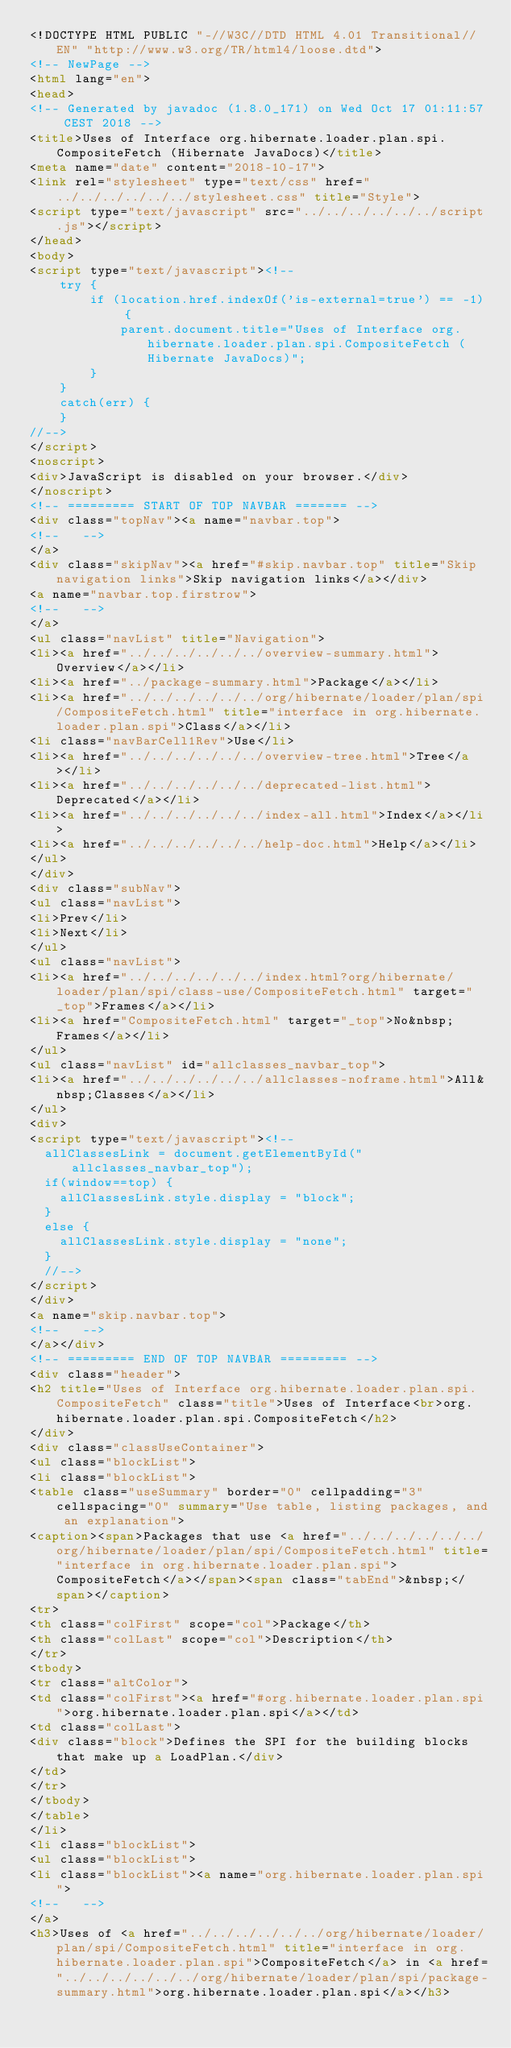Convert code to text. <code><loc_0><loc_0><loc_500><loc_500><_HTML_><!DOCTYPE HTML PUBLIC "-//W3C//DTD HTML 4.01 Transitional//EN" "http://www.w3.org/TR/html4/loose.dtd">
<!-- NewPage -->
<html lang="en">
<head>
<!-- Generated by javadoc (1.8.0_171) on Wed Oct 17 01:11:57 CEST 2018 -->
<title>Uses of Interface org.hibernate.loader.plan.spi.CompositeFetch (Hibernate JavaDocs)</title>
<meta name="date" content="2018-10-17">
<link rel="stylesheet" type="text/css" href="../../../../../../stylesheet.css" title="Style">
<script type="text/javascript" src="../../../../../../script.js"></script>
</head>
<body>
<script type="text/javascript"><!--
    try {
        if (location.href.indexOf('is-external=true') == -1) {
            parent.document.title="Uses of Interface org.hibernate.loader.plan.spi.CompositeFetch (Hibernate JavaDocs)";
        }
    }
    catch(err) {
    }
//-->
</script>
<noscript>
<div>JavaScript is disabled on your browser.</div>
</noscript>
<!-- ========= START OF TOP NAVBAR ======= -->
<div class="topNav"><a name="navbar.top">
<!--   -->
</a>
<div class="skipNav"><a href="#skip.navbar.top" title="Skip navigation links">Skip navigation links</a></div>
<a name="navbar.top.firstrow">
<!--   -->
</a>
<ul class="navList" title="Navigation">
<li><a href="../../../../../../overview-summary.html">Overview</a></li>
<li><a href="../package-summary.html">Package</a></li>
<li><a href="../../../../../../org/hibernate/loader/plan/spi/CompositeFetch.html" title="interface in org.hibernate.loader.plan.spi">Class</a></li>
<li class="navBarCell1Rev">Use</li>
<li><a href="../../../../../../overview-tree.html">Tree</a></li>
<li><a href="../../../../../../deprecated-list.html">Deprecated</a></li>
<li><a href="../../../../../../index-all.html">Index</a></li>
<li><a href="../../../../../../help-doc.html">Help</a></li>
</ul>
</div>
<div class="subNav">
<ul class="navList">
<li>Prev</li>
<li>Next</li>
</ul>
<ul class="navList">
<li><a href="../../../../../../index.html?org/hibernate/loader/plan/spi/class-use/CompositeFetch.html" target="_top">Frames</a></li>
<li><a href="CompositeFetch.html" target="_top">No&nbsp;Frames</a></li>
</ul>
<ul class="navList" id="allclasses_navbar_top">
<li><a href="../../../../../../allclasses-noframe.html">All&nbsp;Classes</a></li>
</ul>
<div>
<script type="text/javascript"><!--
  allClassesLink = document.getElementById("allclasses_navbar_top");
  if(window==top) {
    allClassesLink.style.display = "block";
  }
  else {
    allClassesLink.style.display = "none";
  }
  //-->
</script>
</div>
<a name="skip.navbar.top">
<!--   -->
</a></div>
<!-- ========= END OF TOP NAVBAR ========= -->
<div class="header">
<h2 title="Uses of Interface org.hibernate.loader.plan.spi.CompositeFetch" class="title">Uses of Interface<br>org.hibernate.loader.plan.spi.CompositeFetch</h2>
</div>
<div class="classUseContainer">
<ul class="blockList">
<li class="blockList">
<table class="useSummary" border="0" cellpadding="3" cellspacing="0" summary="Use table, listing packages, and an explanation">
<caption><span>Packages that use <a href="../../../../../../org/hibernate/loader/plan/spi/CompositeFetch.html" title="interface in org.hibernate.loader.plan.spi">CompositeFetch</a></span><span class="tabEnd">&nbsp;</span></caption>
<tr>
<th class="colFirst" scope="col">Package</th>
<th class="colLast" scope="col">Description</th>
</tr>
<tbody>
<tr class="altColor">
<td class="colFirst"><a href="#org.hibernate.loader.plan.spi">org.hibernate.loader.plan.spi</a></td>
<td class="colLast">
<div class="block">Defines the SPI for the building blocks that make up a LoadPlan.</div>
</td>
</tr>
</tbody>
</table>
</li>
<li class="blockList">
<ul class="blockList">
<li class="blockList"><a name="org.hibernate.loader.plan.spi">
<!--   -->
</a>
<h3>Uses of <a href="../../../../../../org/hibernate/loader/plan/spi/CompositeFetch.html" title="interface in org.hibernate.loader.plan.spi">CompositeFetch</a> in <a href="../../../../../../org/hibernate/loader/plan/spi/package-summary.html">org.hibernate.loader.plan.spi</a></h3></code> 